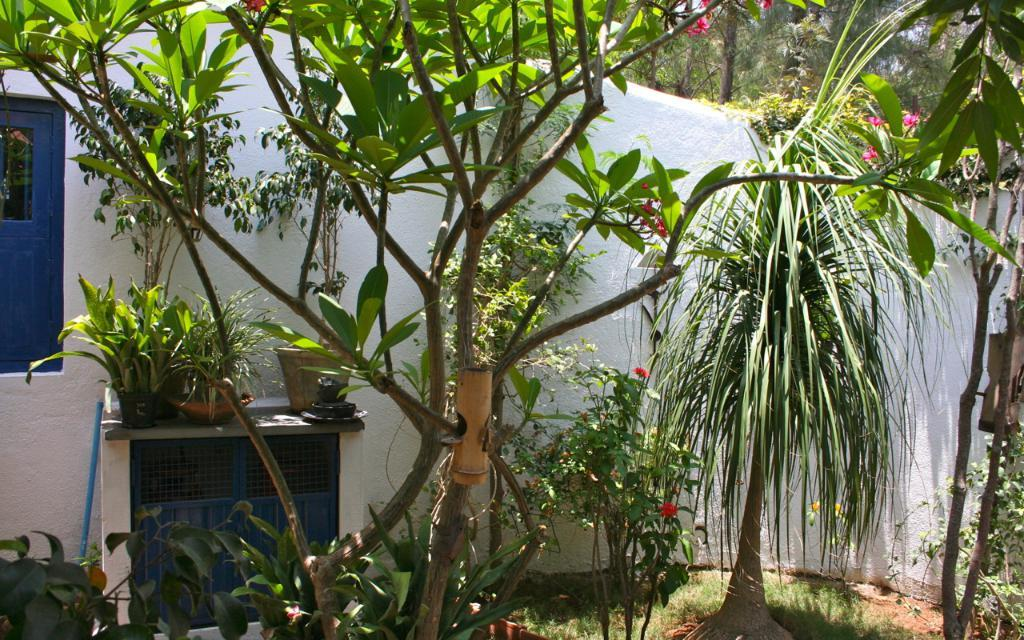What type of vegetation can be seen in the image? There are plants and trees in the image. What architectural feature is present in the image? There is a wall with a window in the image. What type of surface is visible at the bottom of the image? Grass is present on the surface at the bottom of the image. What is the name of the daughter in the image? There is no daughter present in the image. What type of van can be seen parked near the trees? There is no van present in the image. 